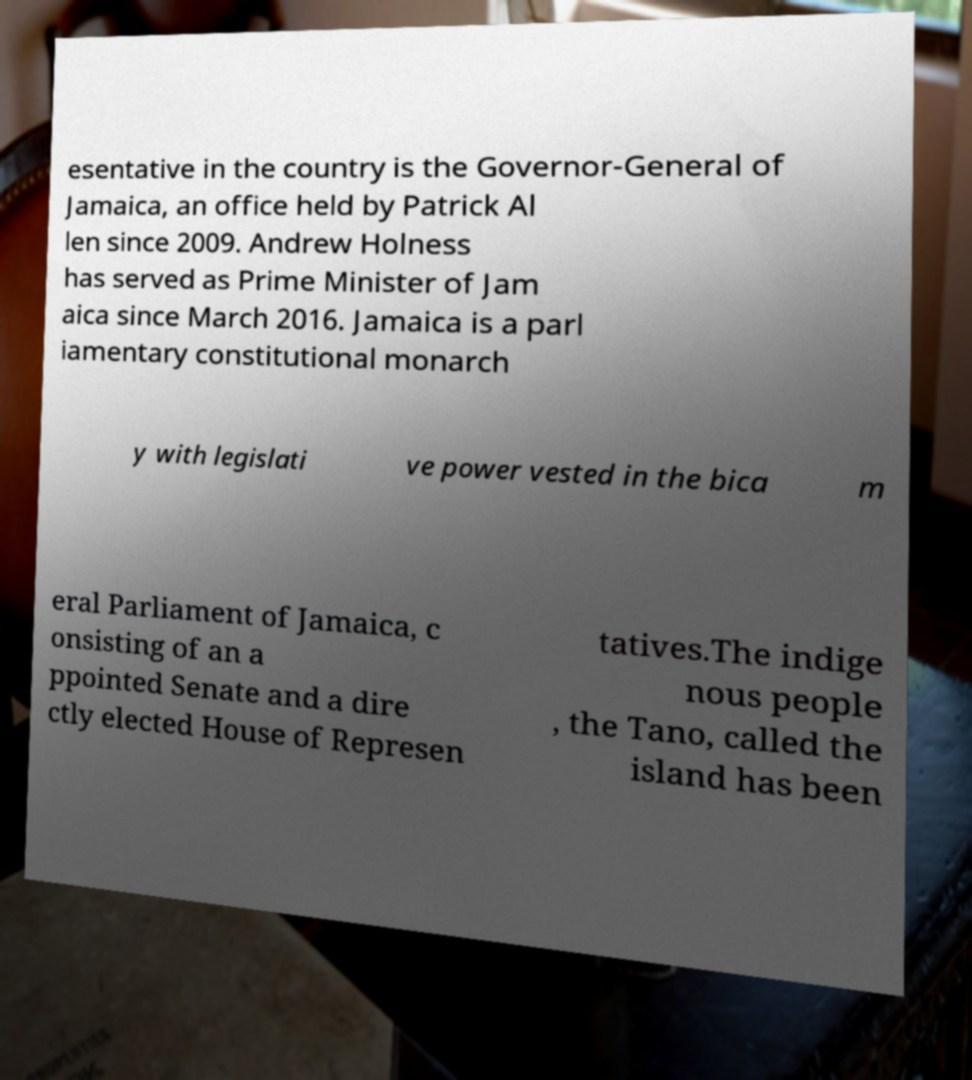Could you extract and type out the text from this image? esentative in the country is the Governor-General of Jamaica, an office held by Patrick Al len since 2009. Andrew Holness has served as Prime Minister of Jam aica since March 2016. Jamaica is a parl iamentary constitutional monarch y with legislati ve power vested in the bica m eral Parliament of Jamaica, c onsisting of an a ppointed Senate and a dire ctly elected House of Represen tatives.The indige nous people , the Tano, called the island has been 